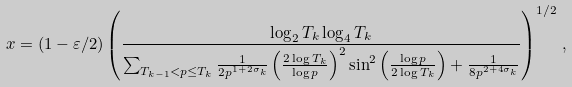<formula> <loc_0><loc_0><loc_500><loc_500>x = ( 1 - \varepsilon / 2 ) \left ( \frac { \log _ { 2 } T _ { k } \log _ { 4 } T _ { k } } { \sum _ { T _ { k - 1 } < p \leq T _ { k } } \frac { 1 } { 2 p ^ { 1 + 2 \sigma _ { k } } } \left ( \frac { 2 \log T _ { k } } { \log p } \right ) ^ { 2 } \sin ^ { 2 } \left ( \frac { \log p } { 2 \log T _ { k } } \right ) + \frac { 1 } { 8 p ^ { 2 + 4 \sigma _ { k } } } } \right ) ^ { 1 / 2 } \, ,</formula> 